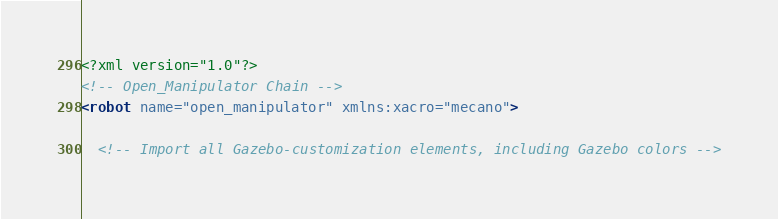Convert code to text. <code><loc_0><loc_0><loc_500><loc_500><_XML_><?xml version="1.0"?>
<!-- Open_Manipulator Chain -->
<robot name="open_manipulator" xmlns:xacro="mecano">

  <!-- Import all Gazebo-customization elements, including Gazebo colors --></code> 